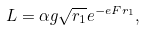Convert formula to latex. <formula><loc_0><loc_0><loc_500><loc_500>L = \alpha g \sqrt { r _ { 1 } } e ^ { - e F r _ { 1 } } ,</formula> 